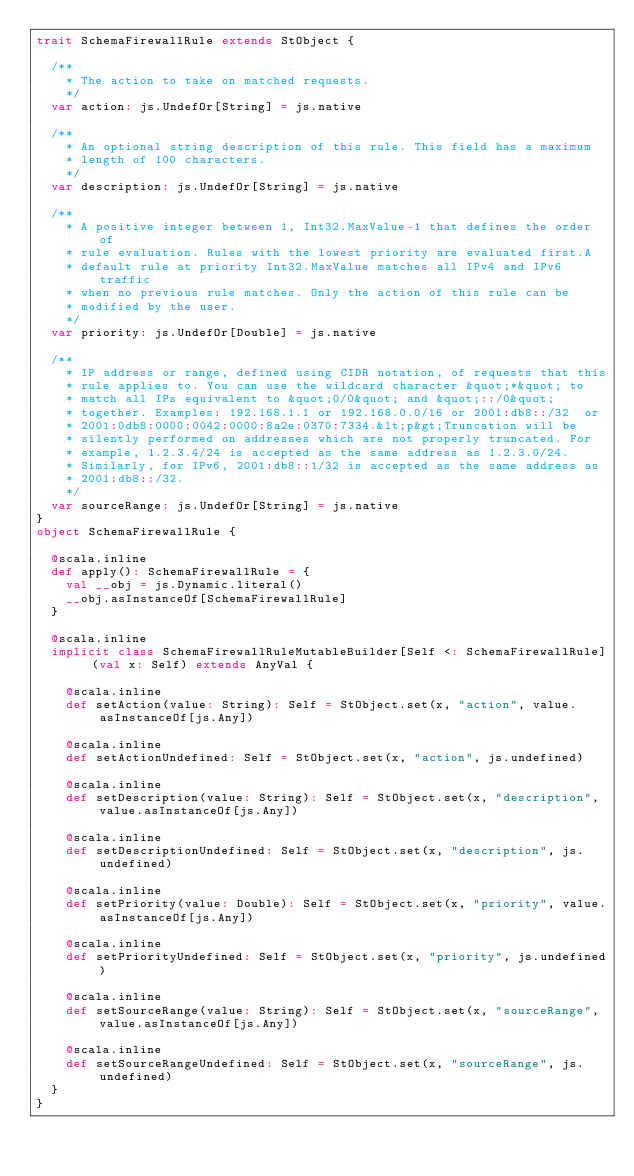<code> <loc_0><loc_0><loc_500><loc_500><_Scala_>trait SchemaFirewallRule extends StObject {
  
  /**
    * The action to take on matched requests.
    */
  var action: js.UndefOr[String] = js.native
  
  /**
    * An optional string description of this rule. This field has a maximum
    * length of 100 characters.
    */
  var description: js.UndefOr[String] = js.native
  
  /**
    * A positive integer between 1, Int32.MaxValue-1 that defines the order of
    * rule evaluation. Rules with the lowest priority are evaluated first.A
    * default rule at priority Int32.MaxValue matches all IPv4 and IPv6 traffic
    * when no previous rule matches. Only the action of this rule can be
    * modified by the user.
    */
  var priority: js.UndefOr[Double] = js.native
  
  /**
    * IP address or range, defined using CIDR notation, of requests that this
    * rule applies to. You can use the wildcard character &quot;*&quot; to
    * match all IPs equivalent to &quot;0/0&quot; and &quot;::/0&quot;
    * together. Examples: 192.168.1.1 or 192.168.0.0/16 or 2001:db8::/32  or
    * 2001:0db8:0000:0042:0000:8a2e:0370:7334.&lt;p&gt;Truncation will be
    * silently performed on addresses which are not properly truncated. For
    * example, 1.2.3.4/24 is accepted as the same address as 1.2.3.0/24.
    * Similarly, for IPv6, 2001:db8::1/32 is accepted as the same address as
    * 2001:db8::/32.
    */
  var sourceRange: js.UndefOr[String] = js.native
}
object SchemaFirewallRule {
  
  @scala.inline
  def apply(): SchemaFirewallRule = {
    val __obj = js.Dynamic.literal()
    __obj.asInstanceOf[SchemaFirewallRule]
  }
  
  @scala.inline
  implicit class SchemaFirewallRuleMutableBuilder[Self <: SchemaFirewallRule] (val x: Self) extends AnyVal {
    
    @scala.inline
    def setAction(value: String): Self = StObject.set(x, "action", value.asInstanceOf[js.Any])
    
    @scala.inline
    def setActionUndefined: Self = StObject.set(x, "action", js.undefined)
    
    @scala.inline
    def setDescription(value: String): Self = StObject.set(x, "description", value.asInstanceOf[js.Any])
    
    @scala.inline
    def setDescriptionUndefined: Self = StObject.set(x, "description", js.undefined)
    
    @scala.inline
    def setPriority(value: Double): Self = StObject.set(x, "priority", value.asInstanceOf[js.Any])
    
    @scala.inline
    def setPriorityUndefined: Self = StObject.set(x, "priority", js.undefined)
    
    @scala.inline
    def setSourceRange(value: String): Self = StObject.set(x, "sourceRange", value.asInstanceOf[js.Any])
    
    @scala.inline
    def setSourceRangeUndefined: Self = StObject.set(x, "sourceRange", js.undefined)
  }
}
</code> 